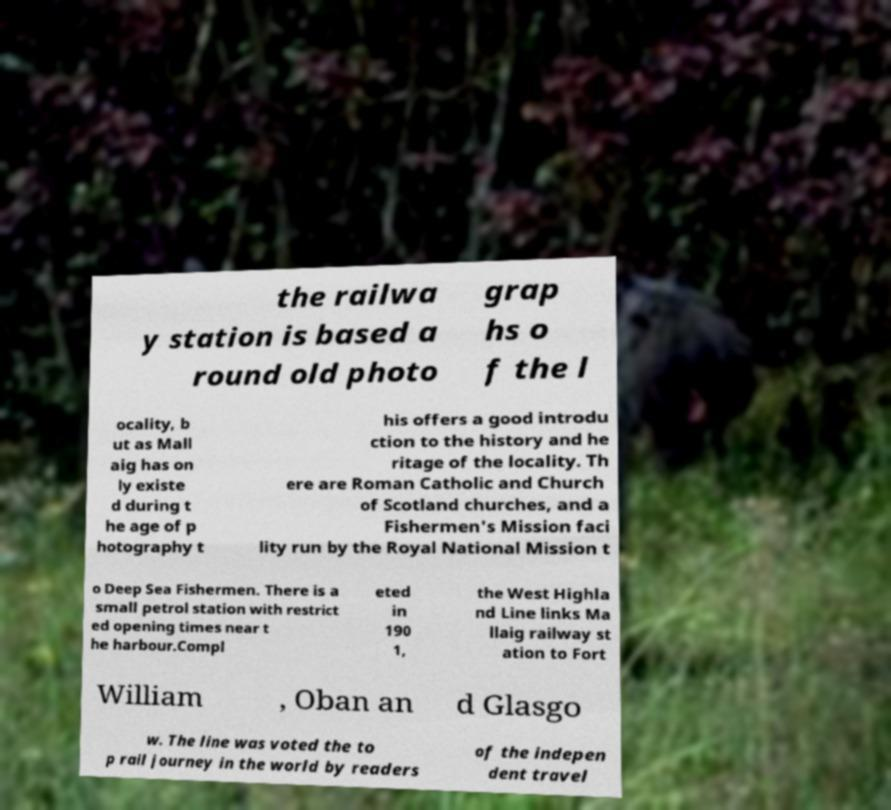Can you accurately transcribe the text from the provided image for me? the railwa y station is based a round old photo grap hs o f the l ocality, b ut as Mall aig has on ly existe d during t he age of p hotography t his offers a good introdu ction to the history and he ritage of the locality. Th ere are Roman Catholic and Church of Scotland churches, and a Fishermen's Mission faci lity run by the Royal National Mission t o Deep Sea Fishermen. There is a small petrol station with restrict ed opening times near t he harbour.Compl eted in 190 1, the West Highla nd Line links Ma llaig railway st ation to Fort William , Oban an d Glasgo w. The line was voted the to p rail journey in the world by readers of the indepen dent travel 